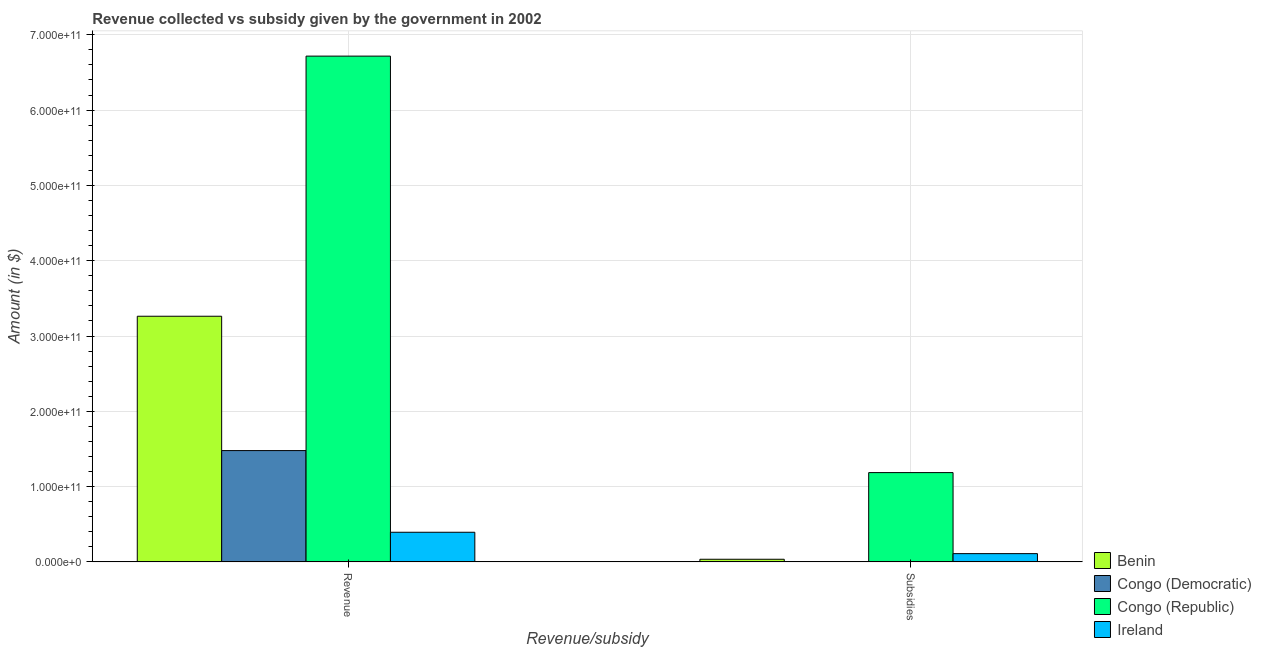How many bars are there on the 2nd tick from the left?
Provide a short and direct response. 4. How many bars are there on the 2nd tick from the right?
Offer a very short reply. 4. What is the label of the 1st group of bars from the left?
Ensure brevity in your answer.  Revenue. What is the amount of subsidies given in Benin?
Offer a terse response. 3.52e+09. Across all countries, what is the maximum amount of subsidies given?
Keep it short and to the point. 1.19e+11. Across all countries, what is the minimum amount of revenue collected?
Keep it short and to the point. 3.94e+1. In which country was the amount of revenue collected maximum?
Your response must be concise. Congo (Republic). In which country was the amount of revenue collected minimum?
Offer a very short reply. Ireland. What is the total amount of subsidies given in the graph?
Provide a succinct answer. 1.34e+11. What is the difference between the amount of revenue collected in Congo (Democratic) and that in Congo (Republic)?
Ensure brevity in your answer.  -5.24e+11. What is the difference between the amount of revenue collected in Benin and the amount of subsidies given in Congo (Republic)?
Your answer should be very brief. 2.08e+11. What is the average amount of revenue collected per country?
Your response must be concise. 2.96e+11. What is the difference between the amount of subsidies given and amount of revenue collected in Congo (Democratic)?
Your answer should be compact. -1.47e+11. What is the ratio of the amount of revenue collected in Benin to that in Congo (Republic)?
Give a very brief answer. 0.49. What does the 4th bar from the left in Subsidies represents?
Your answer should be compact. Ireland. What does the 3rd bar from the right in Subsidies represents?
Provide a succinct answer. Congo (Democratic). What is the difference between two consecutive major ticks on the Y-axis?
Ensure brevity in your answer.  1.00e+11. Are the values on the major ticks of Y-axis written in scientific E-notation?
Make the answer very short. Yes. Does the graph contain any zero values?
Your answer should be very brief. No. Does the graph contain grids?
Make the answer very short. Yes. How many legend labels are there?
Keep it short and to the point. 4. How are the legend labels stacked?
Give a very brief answer. Vertical. What is the title of the graph?
Provide a succinct answer. Revenue collected vs subsidy given by the government in 2002. What is the label or title of the X-axis?
Provide a succinct answer. Revenue/subsidy. What is the label or title of the Y-axis?
Provide a succinct answer. Amount (in $). What is the Amount (in $) of Benin in Revenue?
Offer a very short reply. 3.26e+11. What is the Amount (in $) of Congo (Democratic) in Revenue?
Provide a succinct answer. 1.48e+11. What is the Amount (in $) of Congo (Republic) in Revenue?
Provide a short and direct response. 6.72e+11. What is the Amount (in $) in Ireland in Revenue?
Your response must be concise. 3.94e+1. What is the Amount (in $) in Benin in Subsidies?
Your answer should be compact. 3.52e+09. What is the Amount (in $) of Congo (Democratic) in Subsidies?
Ensure brevity in your answer.  4.16e+08. What is the Amount (in $) in Congo (Republic) in Subsidies?
Your answer should be compact. 1.19e+11. What is the Amount (in $) in Ireland in Subsidies?
Make the answer very short. 1.10e+1. Across all Revenue/subsidy, what is the maximum Amount (in $) in Benin?
Provide a succinct answer. 3.26e+11. Across all Revenue/subsidy, what is the maximum Amount (in $) in Congo (Democratic)?
Offer a terse response. 1.48e+11. Across all Revenue/subsidy, what is the maximum Amount (in $) of Congo (Republic)?
Your response must be concise. 6.72e+11. Across all Revenue/subsidy, what is the maximum Amount (in $) of Ireland?
Provide a succinct answer. 3.94e+1. Across all Revenue/subsidy, what is the minimum Amount (in $) in Benin?
Your response must be concise. 3.52e+09. Across all Revenue/subsidy, what is the minimum Amount (in $) of Congo (Democratic)?
Ensure brevity in your answer.  4.16e+08. Across all Revenue/subsidy, what is the minimum Amount (in $) in Congo (Republic)?
Your answer should be very brief. 1.19e+11. Across all Revenue/subsidy, what is the minimum Amount (in $) of Ireland?
Give a very brief answer. 1.10e+1. What is the total Amount (in $) of Benin in the graph?
Keep it short and to the point. 3.30e+11. What is the total Amount (in $) in Congo (Democratic) in the graph?
Offer a terse response. 1.48e+11. What is the total Amount (in $) of Congo (Republic) in the graph?
Ensure brevity in your answer.  7.90e+11. What is the total Amount (in $) in Ireland in the graph?
Your answer should be compact. 5.04e+1. What is the difference between the Amount (in $) in Benin in Revenue and that in Subsidies?
Your response must be concise. 3.23e+11. What is the difference between the Amount (in $) in Congo (Democratic) in Revenue and that in Subsidies?
Provide a succinct answer. 1.47e+11. What is the difference between the Amount (in $) in Congo (Republic) in Revenue and that in Subsidies?
Provide a short and direct response. 5.53e+11. What is the difference between the Amount (in $) in Ireland in Revenue and that in Subsidies?
Make the answer very short. 2.84e+1. What is the difference between the Amount (in $) in Benin in Revenue and the Amount (in $) in Congo (Democratic) in Subsidies?
Offer a terse response. 3.26e+11. What is the difference between the Amount (in $) in Benin in Revenue and the Amount (in $) in Congo (Republic) in Subsidies?
Offer a very short reply. 2.08e+11. What is the difference between the Amount (in $) in Benin in Revenue and the Amount (in $) in Ireland in Subsidies?
Your answer should be very brief. 3.15e+11. What is the difference between the Amount (in $) of Congo (Democratic) in Revenue and the Amount (in $) of Congo (Republic) in Subsidies?
Your response must be concise. 2.92e+1. What is the difference between the Amount (in $) in Congo (Democratic) in Revenue and the Amount (in $) in Ireland in Subsidies?
Ensure brevity in your answer.  1.37e+11. What is the difference between the Amount (in $) of Congo (Republic) in Revenue and the Amount (in $) of Ireland in Subsidies?
Give a very brief answer. 6.61e+11. What is the average Amount (in $) of Benin per Revenue/subsidy?
Ensure brevity in your answer.  1.65e+11. What is the average Amount (in $) of Congo (Democratic) per Revenue/subsidy?
Your answer should be very brief. 7.41e+1. What is the average Amount (in $) of Congo (Republic) per Revenue/subsidy?
Provide a short and direct response. 3.95e+11. What is the average Amount (in $) of Ireland per Revenue/subsidy?
Your answer should be compact. 2.52e+1. What is the difference between the Amount (in $) of Benin and Amount (in $) of Congo (Democratic) in Revenue?
Make the answer very short. 1.78e+11. What is the difference between the Amount (in $) in Benin and Amount (in $) in Congo (Republic) in Revenue?
Keep it short and to the point. -3.45e+11. What is the difference between the Amount (in $) in Benin and Amount (in $) in Ireland in Revenue?
Provide a short and direct response. 2.87e+11. What is the difference between the Amount (in $) of Congo (Democratic) and Amount (in $) of Congo (Republic) in Revenue?
Ensure brevity in your answer.  -5.24e+11. What is the difference between the Amount (in $) in Congo (Democratic) and Amount (in $) in Ireland in Revenue?
Give a very brief answer. 1.08e+11. What is the difference between the Amount (in $) in Congo (Republic) and Amount (in $) in Ireland in Revenue?
Your answer should be compact. 6.32e+11. What is the difference between the Amount (in $) in Benin and Amount (in $) in Congo (Democratic) in Subsidies?
Provide a succinct answer. 3.10e+09. What is the difference between the Amount (in $) of Benin and Amount (in $) of Congo (Republic) in Subsidies?
Your answer should be compact. -1.15e+11. What is the difference between the Amount (in $) in Benin and Amount (in $) in Ireland in Subsidies?
Ensure brevity in your answer.  -7.47e+09. What is the difference between the Amount (in $) of Congo (Democratic) and Amount (in $) of Congo (Republic) in Subsidies?
Make the answer very short. -1.18e+11. What is the difference between the Amount (in $) of Congo (Democratic) and Amount (in $) of Ireland in Subsidies?
Your answer should be very brief. -1.06e+1. What is the difference between the Amount (in $) in Congo (Republic) and Amount (in $) in Ireland in Subsidies?
Keep it short and to the point. 1.08e+11. What is the ratio of the Amount (in $) in Benin in Revenue to that in Subsidies?
Your response must be concise. 92.73. What is the ratio of the Amount (in $) in Congo (Democratic) in Revenue to that in Subsidies?
Offer a very short reply. 355.4. What is the ratio of the Amount (in $) of Congo (Republic) in Revenue to that in Subsidies?
Provide a succinct answer. 5.66. What is the ratio of the Amount (in $) of Ireland in Revenue to that in Subsidies?
Offer a very short reply. 3.58. What is the difference between the highest and the second highest Amount (in $) of Benin?
Your answer should be compact. 3.23e+11. What is the difference between the highest and the second highest Amount (in $) of Congo (Democratic)?
Your answer should be compact. 1.47e+11. What is the difference between the highest and the second highest Amount (in $) in Congo (Republic)?
Keep it short and to the point. 5.53e+11. What is the difference between the highest and the second highest Amount (in $) of Ireland?
Make the answer very short. 2.84e+1. What is the difference between the highest and the lowest Amount (in $) of Benin?
Ensure brevity in your answer.  3.23e+11. What is the difference between the highest and the lowest Amount (in $) in Congo (Democratic)?
Give a very brief answer. 1.47e+11. What is the difference between the highest and the lowest Amount (in $) in Congo (Republic)?
Keep it short and to the point. 5.53e+11. What is the difference between the highest and the lowest Amount (in $) of Ireland?
Make the answer very short. 2.84e+1. 